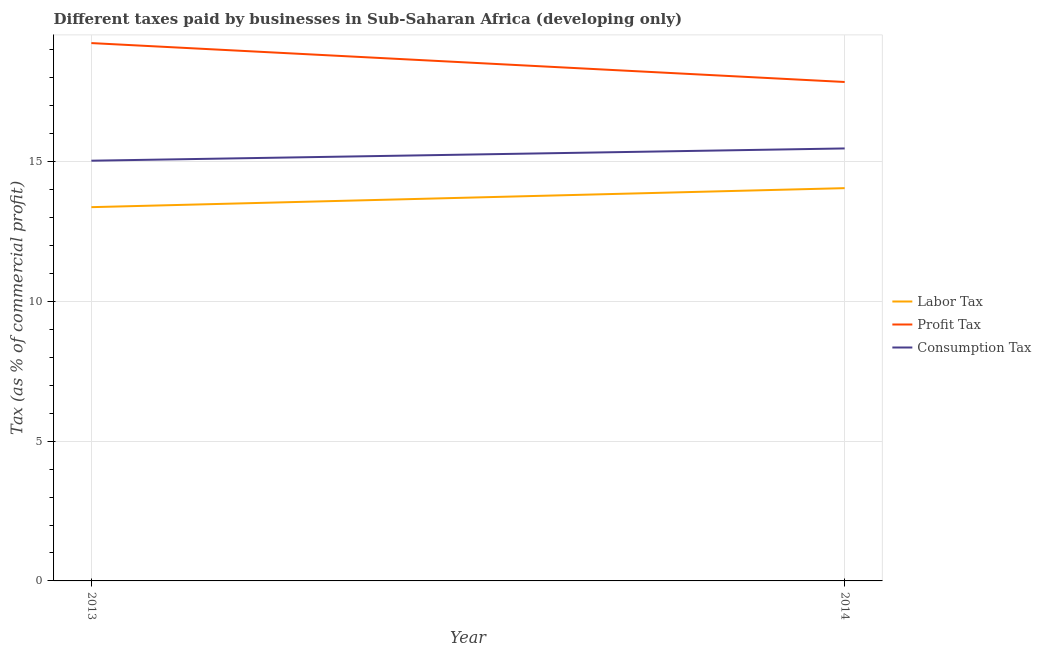Is the number of lines equal to the number of legend labels?
Your answer should be very brief. Yes. What is the percentage of consumption tax in 2013?
Offer a very short reply. 15.03. Across all years, what is the maximum percentage of labor tax?
Your answer should be compact. 14.05. Across all years, what is the minimum percentage of profit tax?
Your response must be concise. 17.85. In which year was the percentage of profit tax minimum?
Provide a short and direct response. 2014. What is the total percentage of profit tax in the graph?
Keep it short and to the point. 37.09. What is the difference between the percentage of consumption tax in 2013 and that in 2014?
Your response must be concise. -0.44. What is the difference between the percentage of profit tax in 2013 and the percentage of consumption tax in 2014?
Your response must be concise. 3.77. What is the average percentage of labor tax per year?
Your answer should be compact. 13.71. In the year 2013, what is the difference between the percentage of consumption tax and percentage of profit tax?
Your response must be concise. -4.21. What is the ratio of the percentage of labor tax in 2013 to that in 2014?
Keep it short and to the point. 0.95. Is the percentage of profit tax strictly greater than the percentage of consumption tax over the years?
Ensure brevity in your answer.  Yes. Is the percentage of consumption tax strictly less than the percentage of profit tax over the years?
Your answer should be compact. Yes. How many lines are there?
Make the answer very short. 3. What is the difference between two consecutive major ticks on the Y-axis?
Your answer should be compact. 5. Are the values on the major ticks of Y-axis written in scientific E-notation?
Give a very brief answer. No. Does the graph contain any zero values?
Your answer should be very brief. No. Where does the legend appear in the graph?
Make the answer very short. Center right. How are the legend labels stacked?
Your answer should be compact. Vertical. What is the title of the graph?
Your response must be concise. Different taxes paid by businesses in Sub-Saharan Africa (developing only). Does "Negligence towards kids" appear as one of the legend labels in the graph?
Offer a very short reply. No. What is the label or title of the Y-axis?
Give a very brief answer. Tax (as % of commercial profit). What is the Tax (as % of commercial profit) of Labor Tax in 2013?
Provide a short and direct response. 13.37. What is the Tax (as % of commercial profit) in Profit Tax in 2013?
Offer a very short reply. 19.24. What is the Tax (as % of commercial profit) in Consumption Tax in 2013?
Provide a succinct answer. 15.03. What is the Tax (as % of commercial profit) in Labor Tax in 2014?
Your answer should be compact. 14.05. What is the Tax (as % of commercial profit) in Profit Tax in 2014?
Provide a succinct answer. 17.85. What is the Tax (as % of commercial profit) in Consumption Tax in 2014?
Provide a succinct answer. 15.47. Across all years, what is the maximum Tax (as % of commercial profit) in Labor Tax?
Your answer should be compact. 14.05. Across all years, what is the maximum Tax (as % of commercial profit) in Profit Tax?
Your answer should be compact. 19.24. Across all years, what is the maximum Tax (as % of commercial profit) in Consumption Tax?
Give a very brief answer. 15.47. Across all years, what is the minimum Tax (as % of commercial profit) in Labor Tax?
Make the answer very short. 13.37. Across all years, what is the minimum Tax (as % of commercial profit) in Profit Tax?
Offer a very short reply. 17.85. Across all years, what is the minimum Tax (as % of commercial profit) of Consumption Tax?
Your response must be concise. 15.03. What is the total Tax (as % of commercial profit) of Labor Tax in the graph?
Keep it short and to the point. 27.42. What is the total Tax (as % of commercial profit) of Profit Tax in the graph?
Your response must be concise. 37.09. What is the total Tax (as % of commercial profit) of Consumption Tax in the graph?
Ensure brevity in your answer.  30.5. What is the difference between the Tax (as % of commercial profit) in Labor Tax in 2013 and that in 2014?
Make the answer very short. -0.68. What is the difference between the Tax (as % of commercial profit) in Profit Tax in 2013 and that in 2014?
Your answer should be compact. 1.39. What is the difference between the Tax (as % of commercial profit) in Consumption Tax in 2013 and that in 2014?
Keep it short and to the point. -0.44. What is the difference between the Tax (as % of commercial profit) of Labor Tax in 2013 and the Tax (as % of commercial profit) of Profit Tax in 2014?
Offer a very short reply. -4.48. What is the difference between the Tax (as % of commercial profit) in Labor Tax in 2013 and the Tax (as % of commercial profit) in Consumption Tax in 2014?
Ensure brevity in your answer.  -2.1. What is the difference between the Tax (as % of commercial profit) in Profit Tax in 2013 and the Tax (as % of commercial profit) in Consumption Tax in 2014?
Offer a very short reply. 3.77. What is the average Tax (as % of commercial profit) in Labor Tax per year?
Offer a very short reply. 13.71. What is the average Tax (as % of commercial profit) in Profit Tax per year?
Provide a short and direct response. 18.54. What is the average Tax (as % of commercial profit) of Consumption Tax per year?
Offer a very short reply. 15.25. In the year 2013, what is the difference between the Tax (as % of commercial profit) of Labor Tax and Tax (as % of commercial profit) of Profit Tax?
Provide a succinct answer. -5.87. In the year 2013, what is the difference between the Tax (as % of commercial profit) of Labor Tax and Tax (as % of commercial profit) of Consumption Tax?
Your response must be concise. -1.66. In the year 2013, what is the difference between the Tax (as % of commercial profit) in Profit Tax and Tax (as % of commercial profit) in Consumption Tax?
Keep it short and to the point. 4.21. In the year 2014, what is the difference between the Tax (as % of commercial profit) in Labor Tax and Tax (as % of commercial profit) in Profit Tax?
Your response must be concise. -3.8. In the year 2014, what is the difference between the Tax (as % of commercial profit) of Labor Tax and Tax (as % of commercial profit) of Consumption Tax?
Provide a succinct answer. -1.42. In the year 2014, what is the difference between the Tax (as % of commercial profit) of Profit Tax and Tax (as % of commercial profit) of Consumption Tax?
Provide a short and direct response. 2.38. What is the ratio of the Tax (as % of commercial profit) in Labor Tax in 2013 to that in 2014?
Make the answer very short. 0.95. What is the ratio of the Tax (as % of commercial profit) of Profit Tax in 2013 to that in 2014?
Provide a succinct answer. 1.08. What is the ratio of the Tax (as % of commercial profit) in Consumption Tax in 2013 to that in 2014?
Provide a short and direct response. 0.97. What is the difference between the highest and the second highest Tax (as % of commercial profit) in Labor Tax?
Keep it short and to the point. 0.68. What is the difference between the highest and the second highest Tax (as % of commercial profit) of Profit Tax?
Offer a terse response. 1.39. What is the difference between the highest and the second highest Tax (as % of commercial profit) in Consumption Tax?
Offer a very short reply. 0.44. What is the difference between the highest and the lowest Tax (as % of commercial profit) in Labor Tax?
Keep it short and to the point. 0.68. What is the difference between the highest and the lowest Tax (as % of commercial profit) of Profit Tax?
Your answer should be compact. 1.39. What is the difference between the highest and the lowest Tax (as % of commercial profit) in Consumption Tax?
Keep it short and to the point. 0.44. 